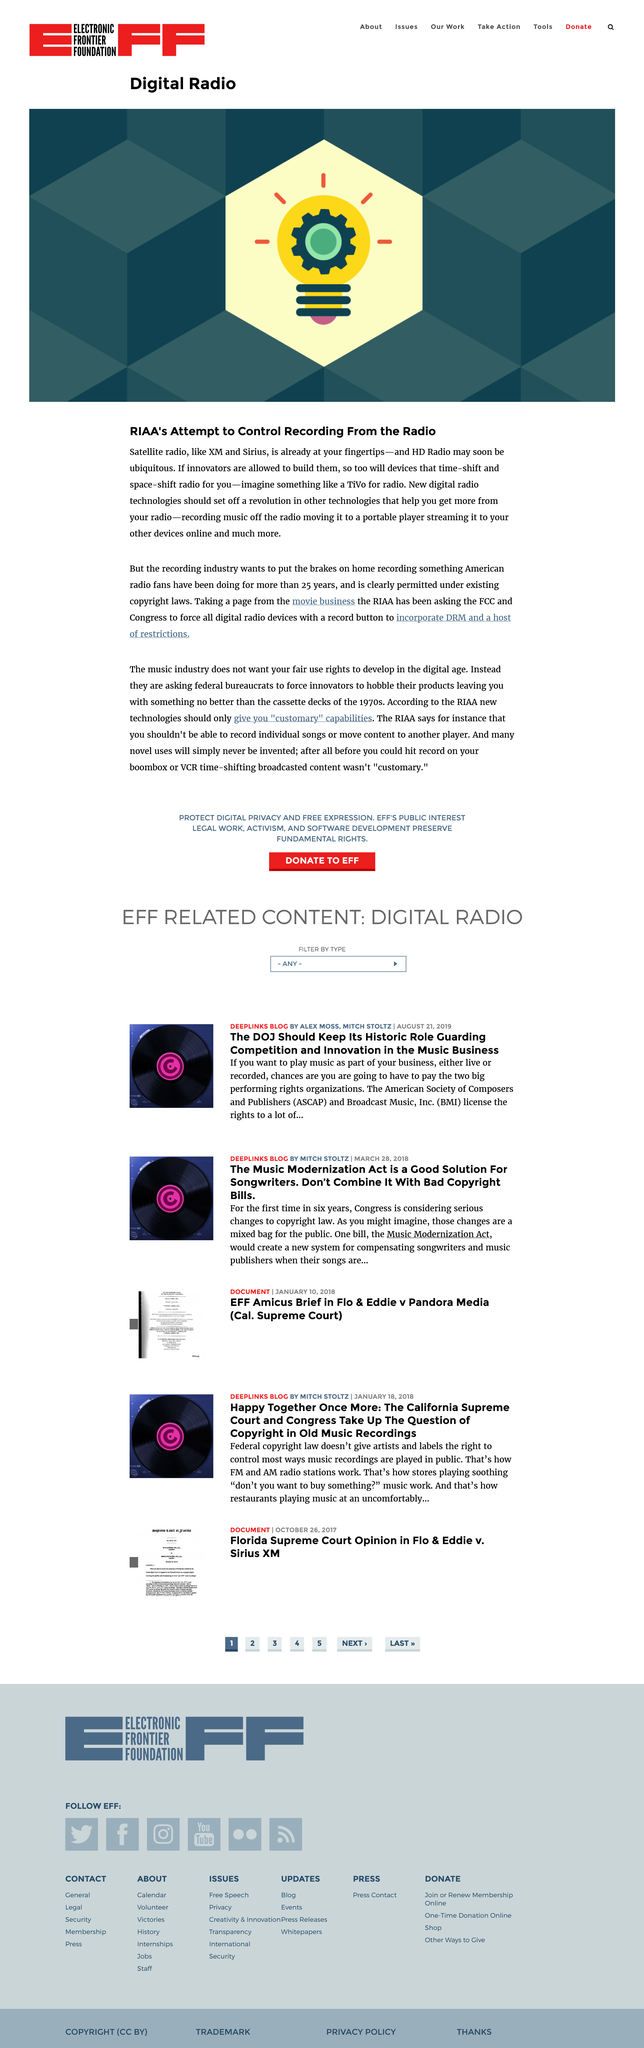Outline some significant characteristics in this image. Yes, according to the article "Digital Radio," satellite radio is already available at the fingertips of its readers. The title of the page is "Digital Radio". The image contains a light bulb, which is the picture. 